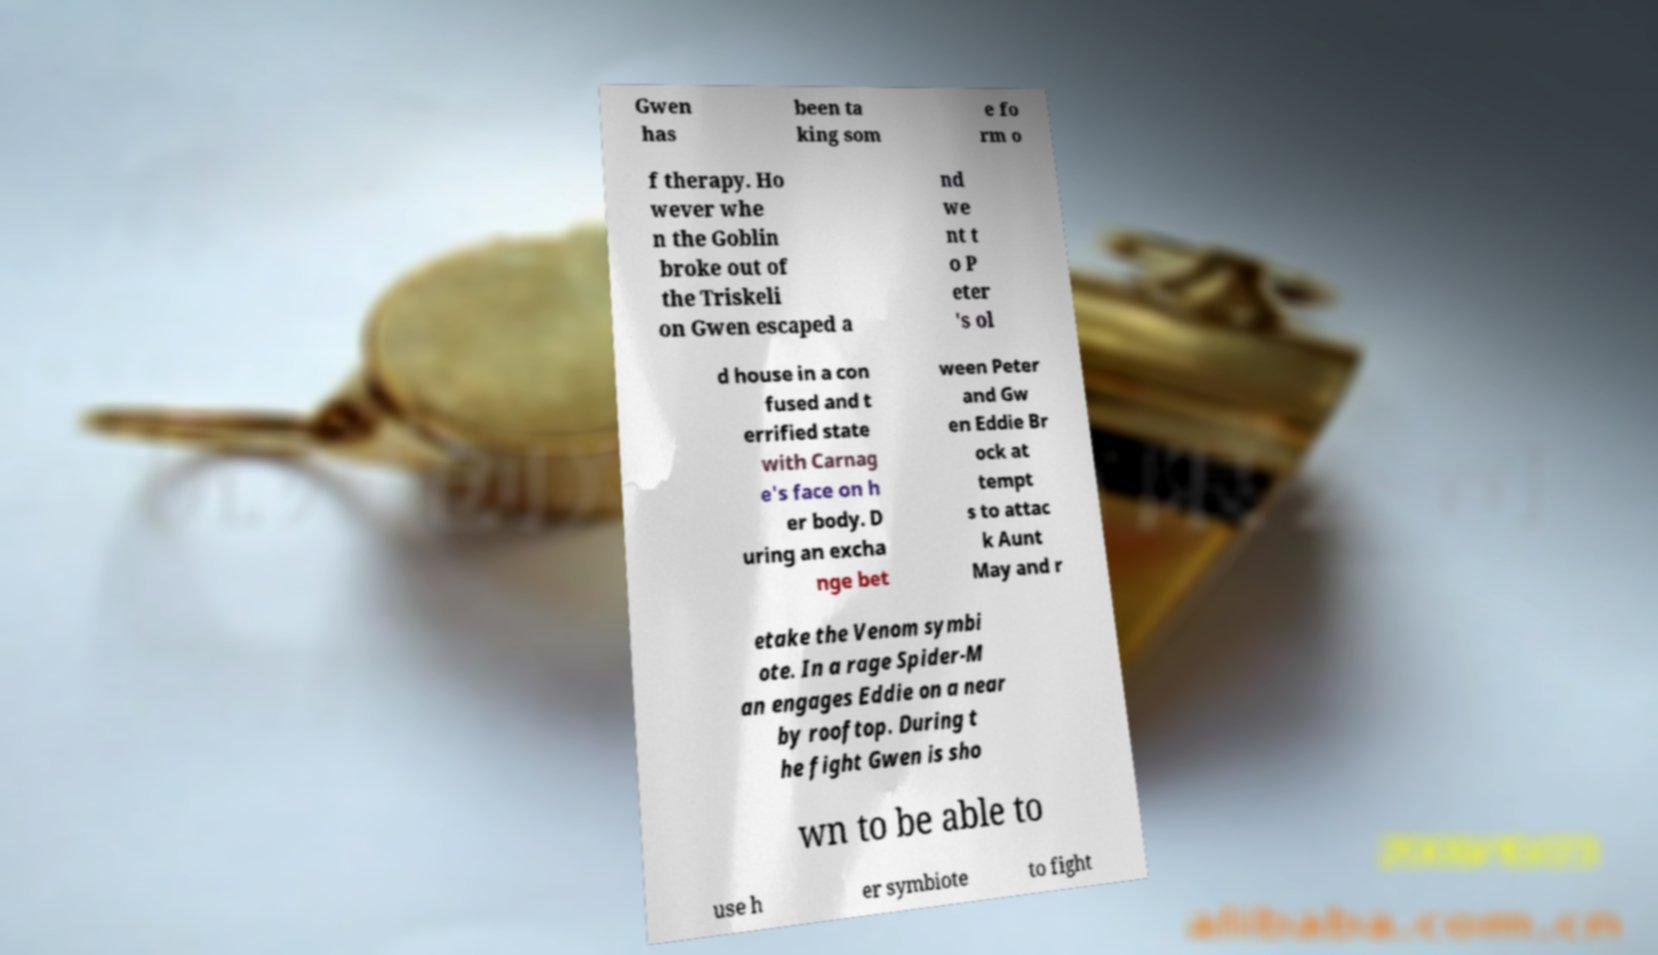For documentation purposes, I need the text within this image transcribed. Could you provide that? Gwen has been ta king som e fo rm o f therapy. Ho wever whe n the Goblin broke out of the Triskeli on Gwen escaped a nd we nt t o P eter 's ol d house in a con fused and t errified state with Carnag e's face on h er body. D uring an excha nge bet ween Peter and Gw en Eddie Br ock at tempt s to attac k Aunt May and r etake the Venom symbi ote. In a rage Spider-M an engages Eddie on a near by rooftop. During t he fight Gwen is sho wn to be able to use h er symbiote to fight 